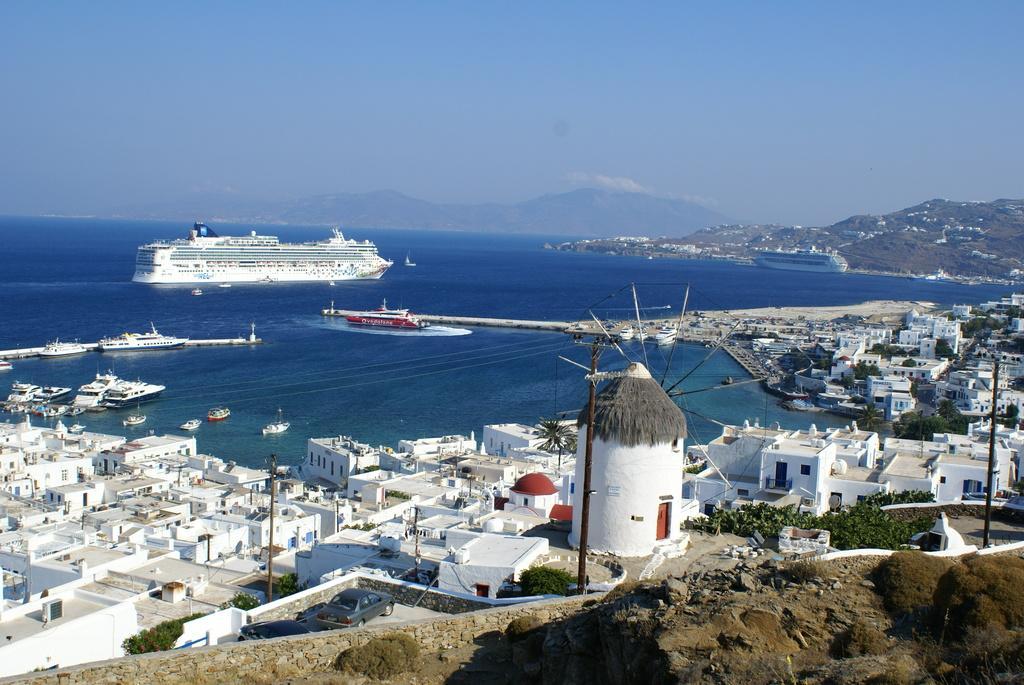In one or two sentences, can you explain what this image depicts? In this image there is a sea, on that sea there are ships near to the sea there are houses, in the background there are mountains and a blue sky. 